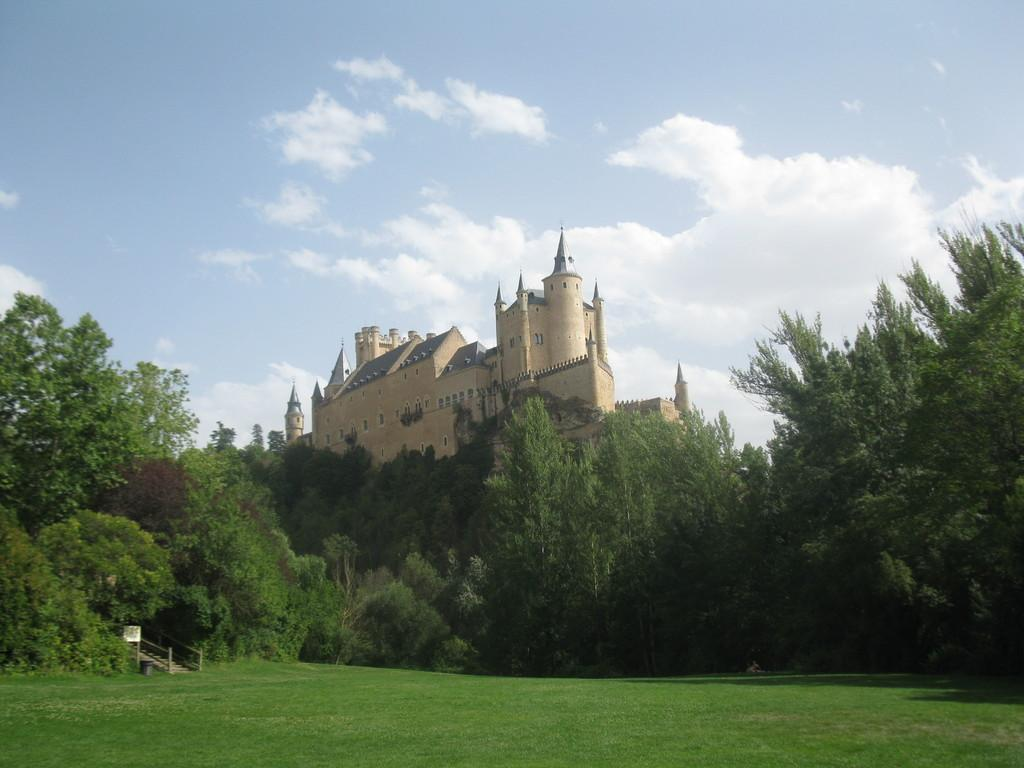What is the main structure in the image? There is a building in the middle of the image. What can be seen in front of the building? There are trees, a board, steps, a bin, and grass in front of the building. How many elements are present in front of the building? There are six elements present in front of the building: trees, a board, steps, a bin, and grass. What is visible in the background of the image? The sky is visible in the background of the image, and it appears to be cloudy. What type of company is represented by the turkey on the board in front of the building? There is no turkey present on the board in front of the building. What is the title of the book that is being read by the person in the image? There is no person or book visible in the image. 